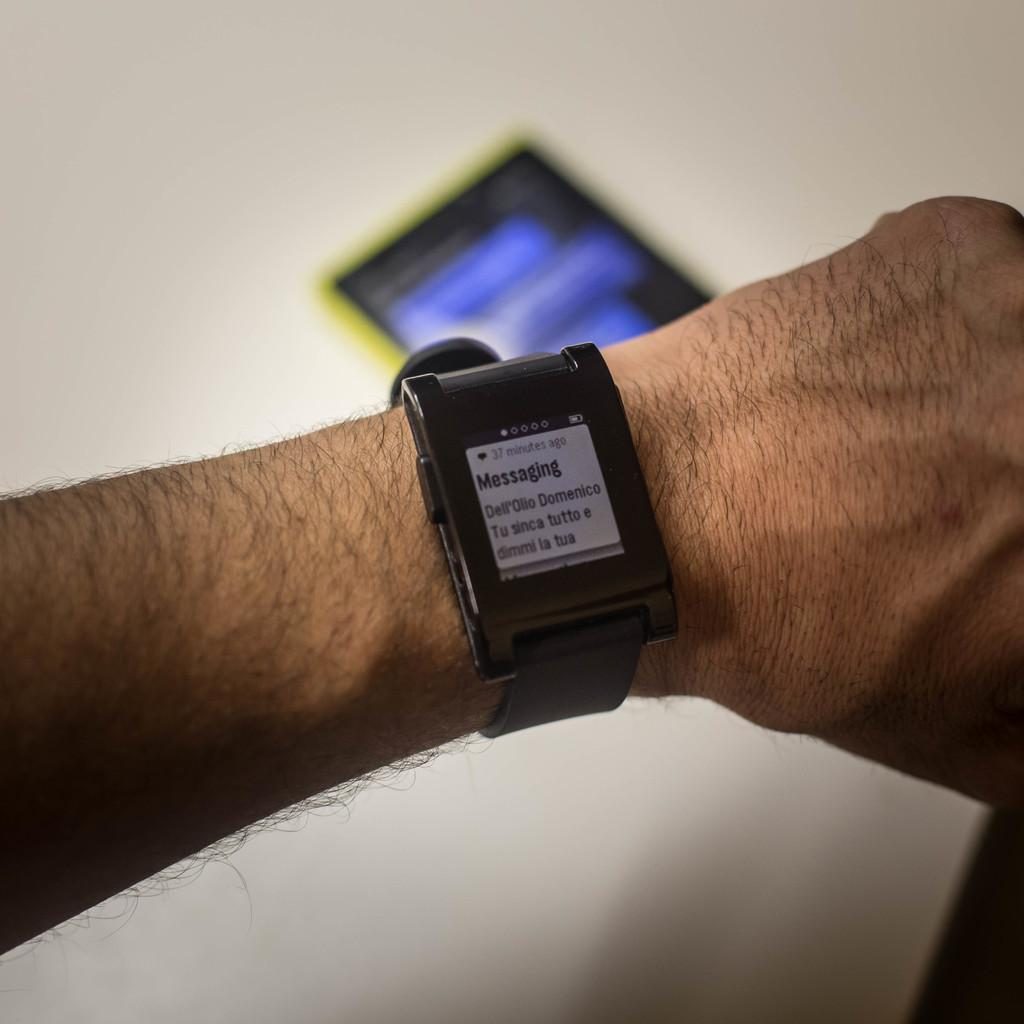<image>
Share a concise interpretation of the image provided. A smart watch on a mans arm displays a message. 